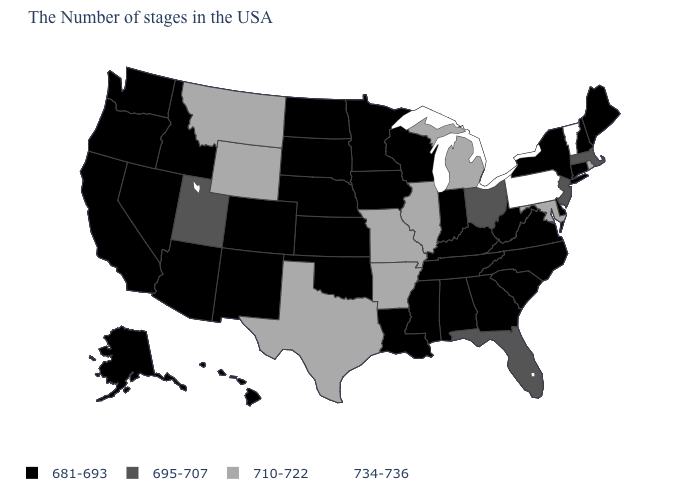Name the states that have a value in the range 710-722?
Be succinct. Rhode Island, Maryland, Michigan, Illinois, Missouri, Arkansas, Texas, Wyoming, Montana. Name the states that have a value in the range 681-693?
Concise answer only. Maine, New Hampshire, Connecticut, New York, Delaware, Virginia, North Carolina, South Carolina, West Virginia, Georgia, Kentucky, Indiana, Alabama, Tennessee, Wisconsin, Mississippi, Louisiana, Minnesota, Iowa, Kansas, Nebraska, Oklahoma, South Dakota, North Dakota, Colorado, New Mexico, Arizona, Idaho, Nevada, California, Washington, Oregon, Alaska, Hawaii. What is the value of New York?
Quick response, please. 681-693. What is the value of Wyoming?
Keep it brief. 710-722. Does Hawaii have the lowest value in the West?
Answer briefly. Yes. What is the value of Alabama?
Write a very short answer. 681-693. Does Pennsylvania have the highest value in the USA?
Quick response, please. Yes. Name the states that have a value in the range 681-693?
Quick response, please. Maine, New Hampshire, Connecticut, New York, Delaware, Virginia, North Carolina, South Carolina, West Virginia, Georgia, Kentucky, Indiana, Alabama, Tennessee, Wisconsin, Mississippi, Louisiana, Minnesota, Iowa, Kansas, Nebraska, Oklahoma, South Dakota, North Dakota, Colorado, New Mexico, Arizona, Idaho, Nevada, California, Washington, Oregon, Alaska, Hawaii. What is the highest value in the Northeast ?
Concise answer only. 734-736. What is the lowest value in states that border Utah?
Answer briefly. 681-693. Name the states that have a value in the range 710-722?
Short answer required. Rhode Island, Maryland, Michigan, Illinois, Missouri, Arkansas, Texas, Wyoming, Montana. Name the states that have a value in the range 734-736?
Answer briefly. Vermont, Pennsylvania. What is the lowest value in the Northeast?
Short answer required. 681-693. Does Massachusetts have the lowest value in the USA?
Answer briefly. No. Name the states that have a value in the range 734-736?
Write a very short answer. Vermont, Pennsylvania. 